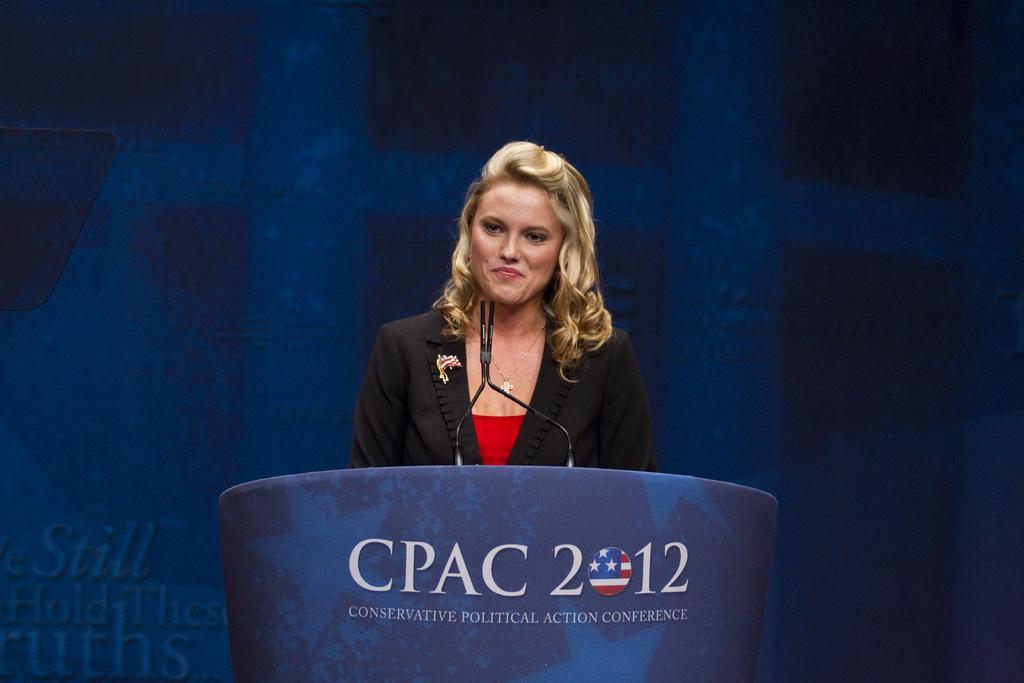Could you give a brief overview of what you see in this image? In this image I can see the person standing in front of the podium and I can also see a microphone and the person is wearing black and red color dress and I can see the blue color background. 